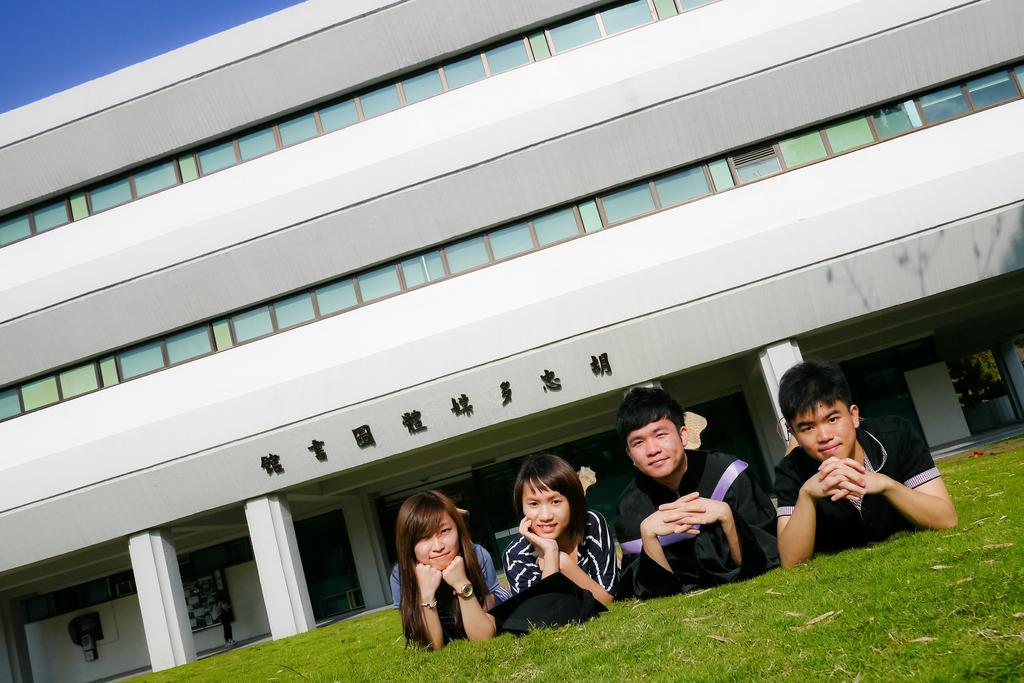What are the people in the image doing? The people in the image are lying on the ground. Can you describe any accessories or clothing items in the image? There is a hat in the image. What can be seen in the background of the image? There is a building in the background of the image. What is visible at the top of the image? The sky is visible at the top of the image. What type of soda is being served at the cookout in the image? There is no cookout or soda present in the image; it features people lying on the ground with a hat and a building in the background. What type of rock is being used as a pillow by the person in the image? There is no rock visible in the image; the people are lying on the ground without any specific objects mentioned as pillows. 